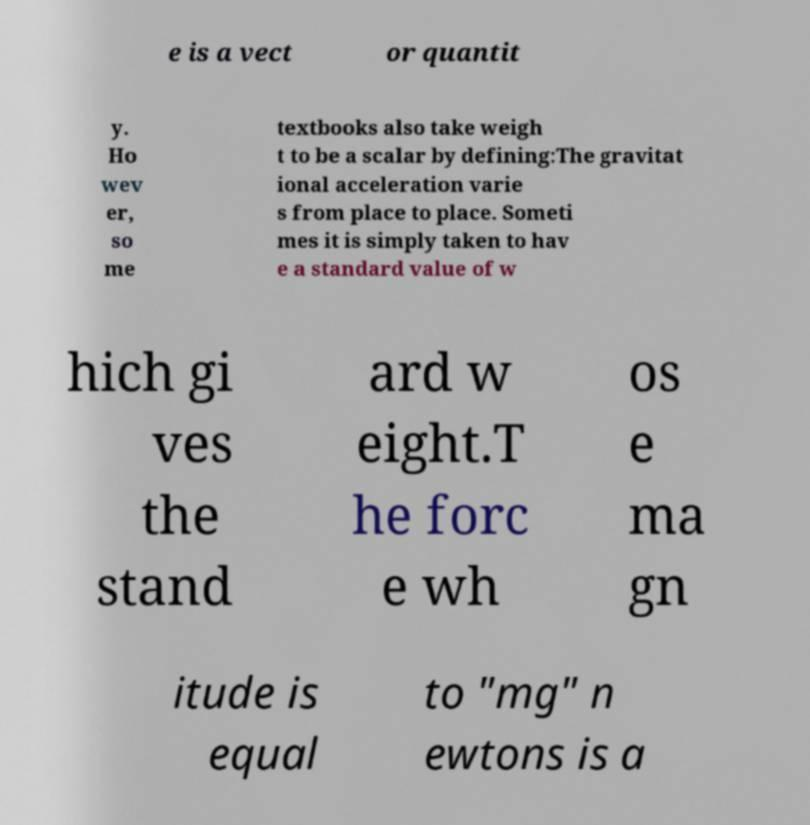Can you explain why understanding gravitational acceleration is important in physics? Gravitational acceleration is crucial because it describes the rate at which objects accelerate towards each other due to gravity. This understanding helps in calculating forces, predicting orbital paths, and understanding universal phenomena like black holes and planetary motion. 